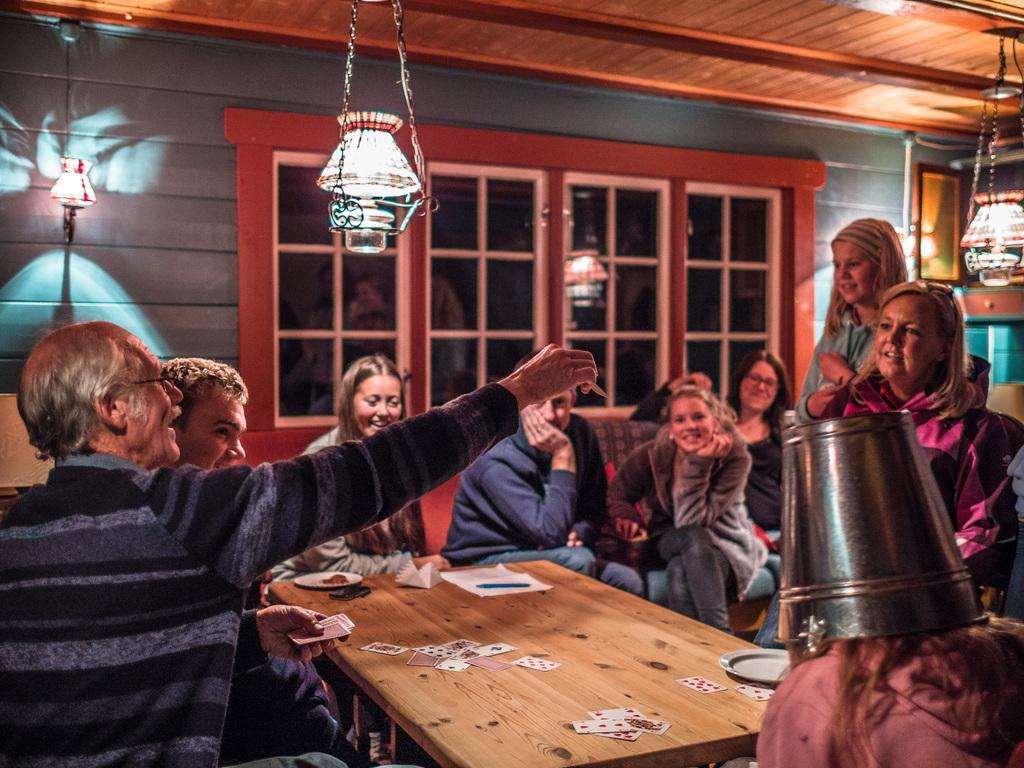Can you describe this image briefly? Few people are playing cards sitting around a table. Few other people watching them sitting beside. 